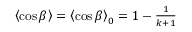<formula> <loc_0><loc_0><loc_500><loc_500>\begin{array} { r } { \left \langle \cos \beta \right \rangle = \left \langle \cos \beta \right \rangle _ { 0 } = 1 - \frac { 1 } { k + 1 } \, } \end{array}</formula> 